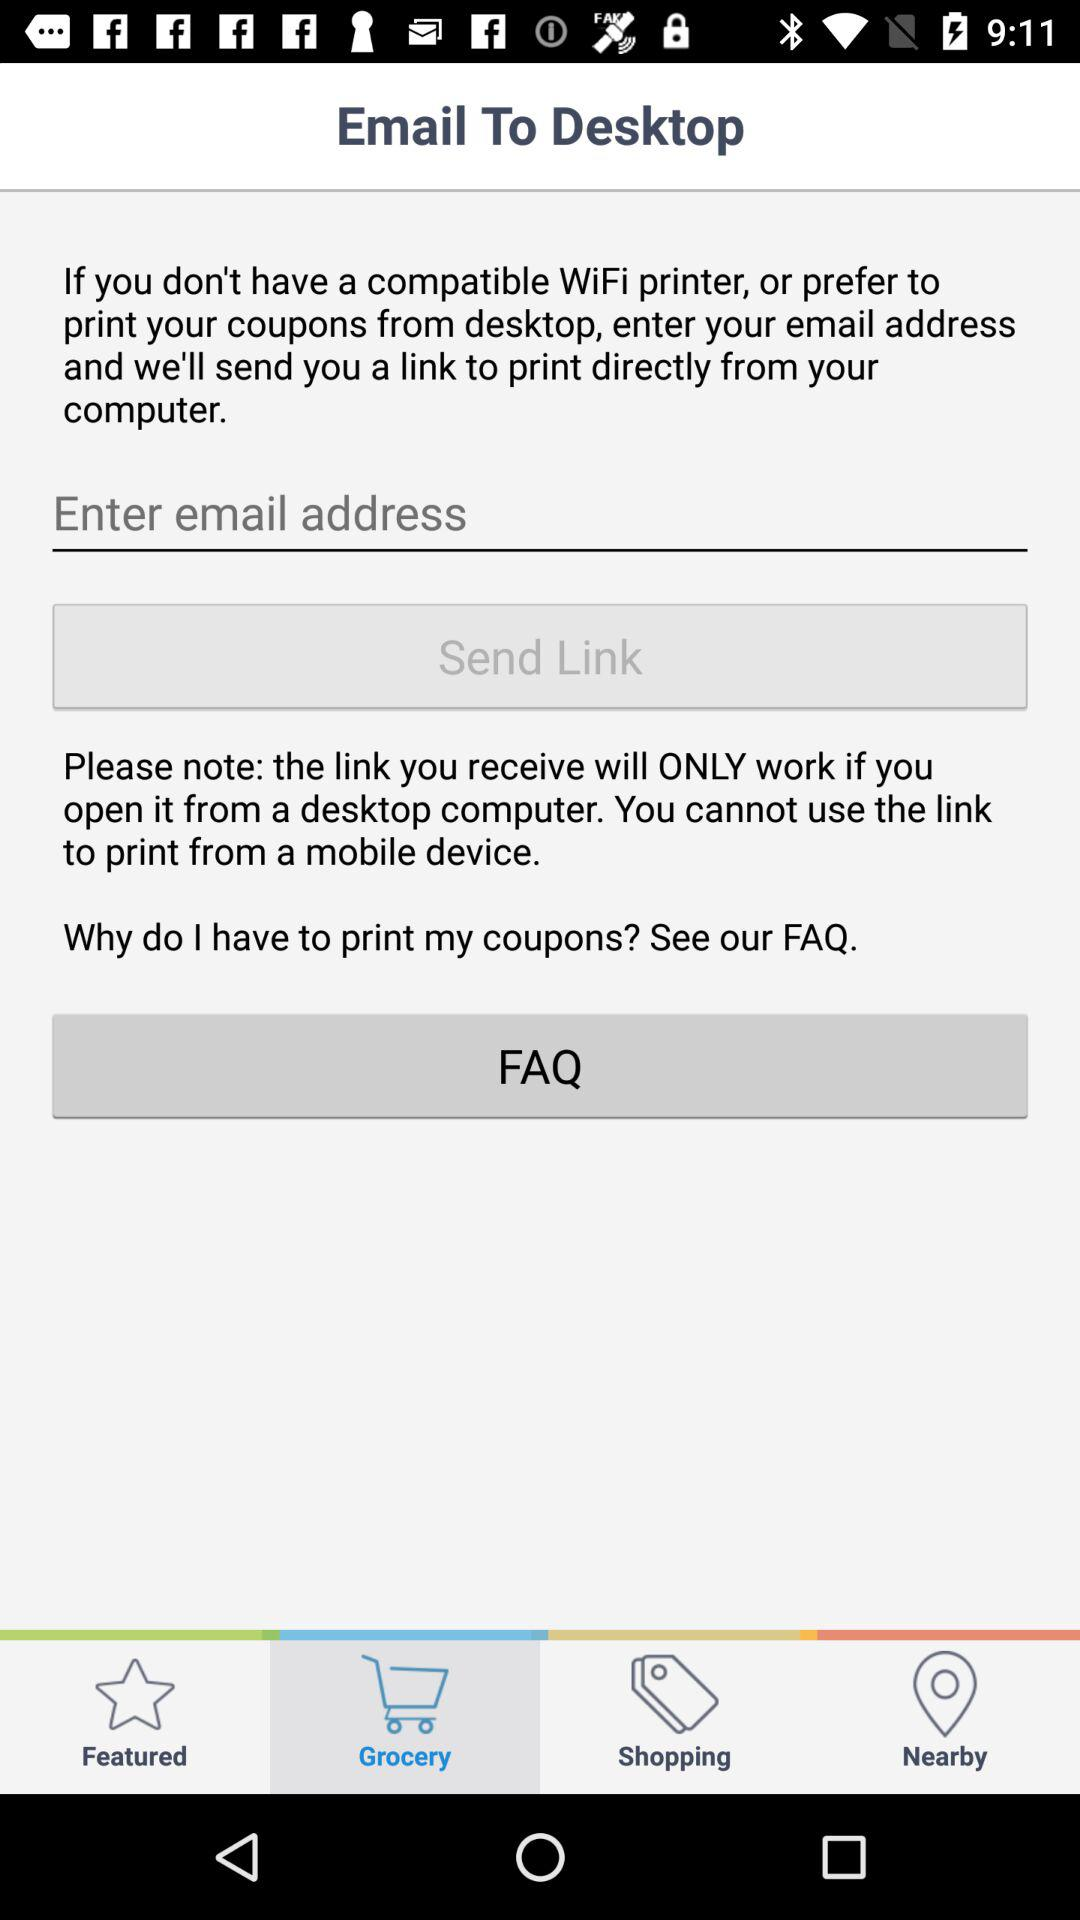Which tab is selected? The selected tab is "Grocery". 